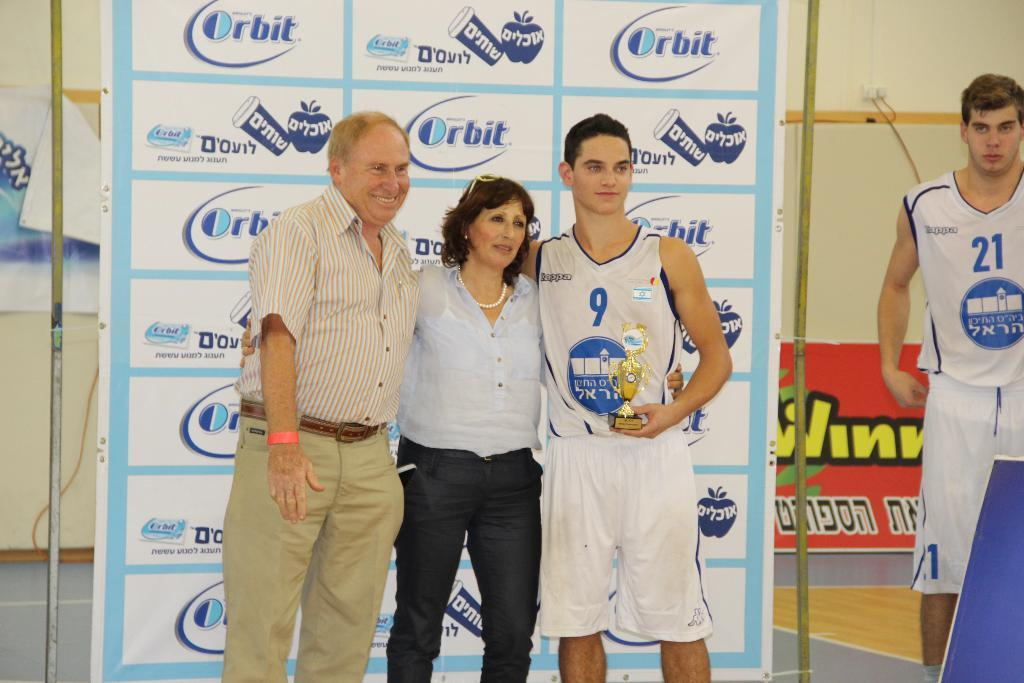<image>
Provide a brief description of the given image. A man and woman pose with basketball player #9 in front of an Orbit backdrop while #21 waits on the side. 